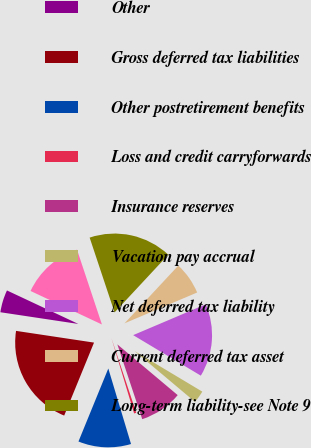Convert chart to OTSL. <chart><loc_0><loc_0><loc_500><loc_500><pie_chart><fcel>Pensionplans<fcel>Other<fcel>Gross deferred tax liabilities<fcel>Other postretirement benefits<fcel>Loss and credit carryforwards<fcel>Insurance reserves<fcel>Vacation pay accrual<fcel>Net deferred tax liability<fcel>Current deferred tax asset<fcel>Long-term liability-see Note 9<nl><fcel>12.9%<fcel>4.61%<fcel>21.2%<fcel>10.83%<fcel>0.46%<fcel>8.76%<fcel>2.54%<fcel>14.98%<fcel>6.68%<fcel>17.05%<nl></chart> 